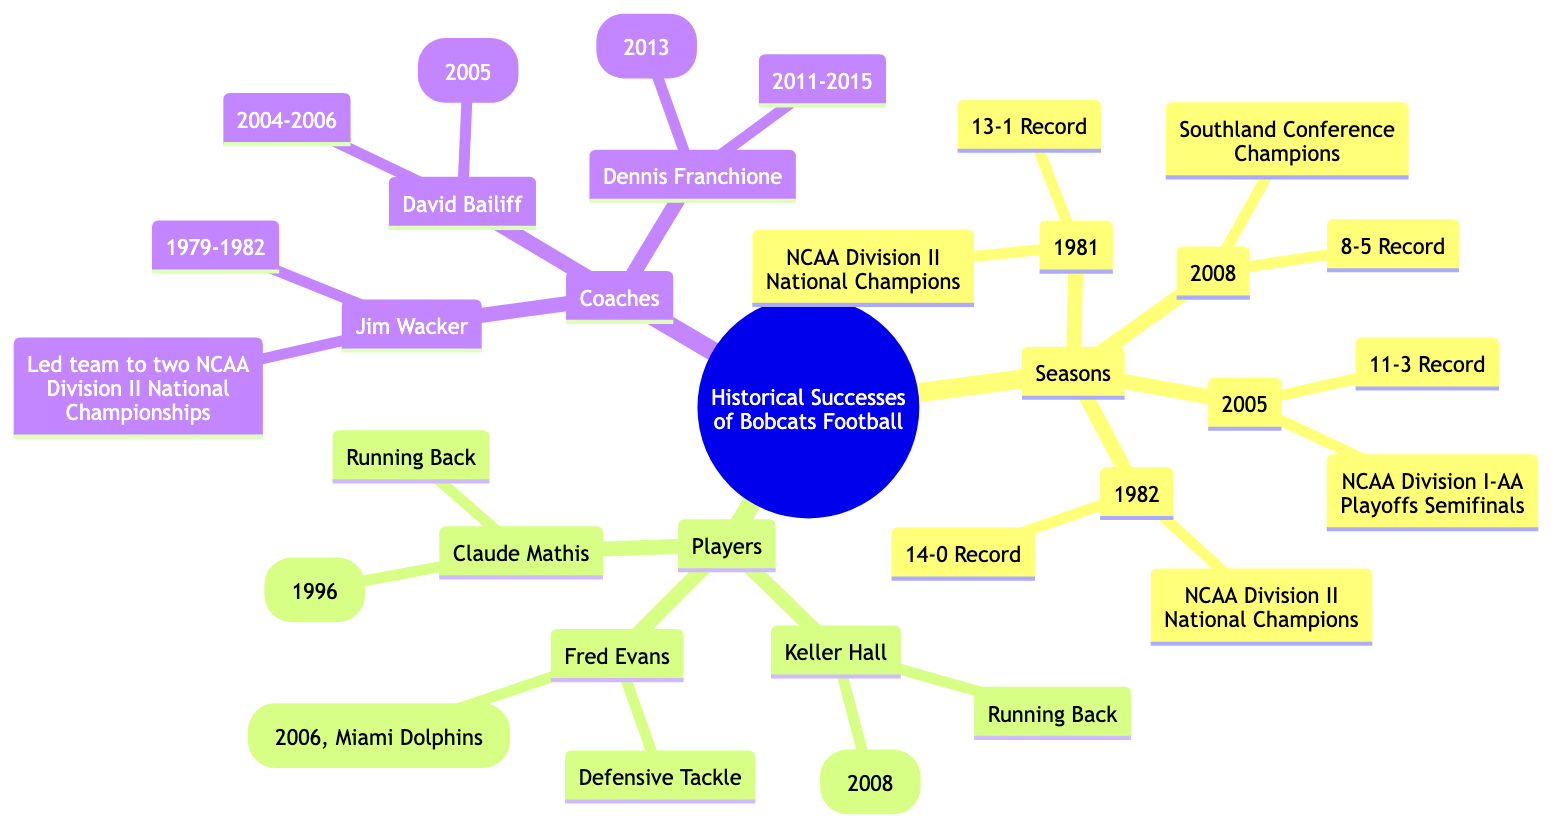What were the achievements of the Bobcats football team in 1981? The diagram specifies that in 1981, the achievement was "NCAA Division II National Champions."
Answer: NCAA Division II National Champions Which player was a Defensive Tackle and an NFL Draft Pick? According to the diagram, Fred Evans played as a Defensive Tackle and was an NFL Draft Pick in 2006 by the Miami Dolphins.
Answer: Fred Evans How many seasons are highlighted in the mind map? By counting the number of years listed under the "Seasons" node, there are four distinct seasons: 1981, 1982, 2005, and 2008.
Answer: 4 Which coach led the team to their first bowl-eligible season? The diagram indicates that Dennis Franchione was the coach during the transition to FBS and led the team to their first bowl-eligible season in 2013.
Answer: Dennis Franchione What year did Keller Hall achieve All-American Selection? The diagram shows that Keller Hall received the All-American Selection in 2008.
Answer: 2008 Name a player who was recognized as Southland Conference Player of the Year. Claude Mathis is identified in the diagram as the Southland Conference Player of the Year in 1996.
Answer: Claude Mathis What is the record of the Bobcats during the 1982 season? The diagram specifies that the record for the Bobcats in 1982 was 14-0.
Answer: 14-0 Which coach led the team from 2004 to 2006? According to the mind map, David Bailiff was the coach during that time frame.
Answer: David Bailiff Which season did the Bobcats achieve a record of 11-3? The diagram indicates that the Bobcats had a record of 11-3 in the 2005 season.
Answer: 2005 